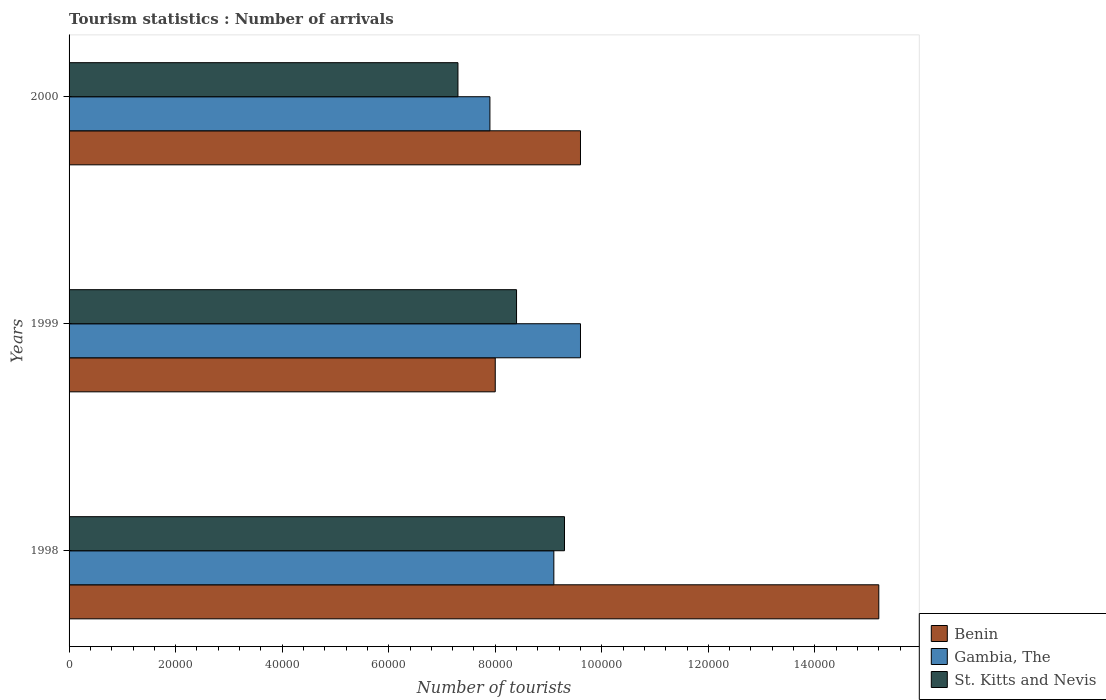How many different coloured bars are there?
Your answer should be very brief. 3. Are the number of bars per tick equal to the number of legend labels?
Keep it short and to the point. Yes. Are the number of bars on each tick of the Y-axis equal?
Provide a succinct answer. Yes. How many bars are there on the 3rd tick from the top?
Keep it short and to the point. 3. What is the label of the 1st group of bars from the top?
Provide a succinct answer. 2000. In how many cases, is the number of bars for a given year not equal to the number of legend labels?
Offer a terse response. 0. What is the number of tourist arrivals in St. Kitts and Nevis in 1998?
Keep it short and to the point. 9.30e+04. Across all years, what is the maximum number of tourist arrivals in Benin?
Keep it short and to the point. 1.52e+05. Across all years, what is the minimum number of tourist arrivals in St. Kitts and Nevis?
Keep it short and to the point. 7.30e+04. What is the total number of tourist arrivals in St. Kitts and Nevis in the graph?
Your answer should be very brief. 2.50e+05. What is the difference between the number of tourist arrivals in Benin in 1998 and that in 1999?
Provide a succinct answer. 7.20e+04. What is the difference between the number of tourist arrivals in Gambia, The in 1998 and the number of tourist arrivals in Benin in 1999?
Make the answer very short. 1.10e+04. What is the average number of tourist arrivals in St. Kitts and Nevis per year?
Keep it short and to the point. 8.33e+04. In the year 2000, what is the difference between the number of tourist arrivals in St. Kitts and Nevis and number of tourist arrivals in Gambia, The?
Provide a succinct answer. -6000. In how many years, is the number of tourist arrivals in St. Kitts and Nevis greater than 144000 ?
Your answer should be very brief. 0. What is the ratio of the number of tourist arrivals in Gambia, The in 1998 to that in 2000?
Give a very brief answer. 1.15. What is the difference between the highest and the second highest number of tourist arrivals in Gambia, The?
Ensure brevity in your answer.  5000. What is the difference between the highest and the lowest number of tourist arrivals in Benin?
Offer a very short reply. 7.20e+04. Is the sum of the number of tourist arrivals in Gambia, The in 1999 and 2000 greater than the maximum number of tourist arrivals in Benin across all years?
Keep it short and to the point. Yes. What does the 3rd bar from the top in 2000 represents?
Provide a short and direct response. Benin. What does the 3rd bar from the bottom in 1999 represents?
Provide a short and direct response. St. Kitts and Nevis. Is it the case that in every year, the sum of the number of tourist arrivals in St. Kitts and Nevis and number of tourist arrivals in Gambia, The is greater than the number of tourist arrivals in Benin?
Your answer should be compact. Yes. How many bars are there?
Keep it short and to the point. 9. Are the values on the major ticks of X-axis written in scientific E-notation?
Make the answer very short. No. Does the graph contain any zero values?
Provide a short and direct response. No. How many legend labels are there?
Your answer should be compact. 3. What is the title of the graph?
Make the answer very short. Tourism statistics : Number of arrivals. Does "Benin" appear as one of the legend labels in the graph?
Make the answer very short. Yes. What is the label or title of the X-axis?
Keep it short and to the point. Number of tourists. What is the label or title of the Y-axis?
Provide a succinct answer. Years. What is the Number of tourists of Benin in 1998?
Keep it short and to the point. 1.52e+05. What is the Number of tourists in Gambia, The in 1998?
Offer a terse response. 9.10e+04. What is the Number of tourists in St. Kitts and Nevis in 1998?
Make the answer very short. 9.30e+04. What is the Number of tourists in Benin in 1999?
Provide a short and direct response. 8.00e+04. What is the Number of tourists of Gambia, The in 1999?
Keep it short and to the point. 9.60e+04. What is the Number of tourists in St. Kitts and Nevis in 1999?
Offer a terse response. 8.40e+04. What is the Number of tourists in Benin in 2000?
Your answer should be very brief. 9.60e+04. What is the Number of tourists in Gambia, The in 2000?
Ensure brevity in your answer.  7.90e+04. What is the Number of tourists in St. Kitts and Nevis in 2000?
Your answer should be compact. 7.30e+04. Across all years, what is the maximum Number of tourists of Benin?
Keep it short and to the point. 1.52e+05. Across all years, what is the maximum Number of tourists of Gambia, The?
Your answer should be compact. 9.60e+04. Across all years, what is the maximum Number of tourists in St. Kitts and Nevis?
Provide a succinct answer. 9.30e+04. Across all years, what is the minimum Number of tourists in Gambia, The?
Your answer should be compact. 7.90e+04. Across all years, what is the minimum Number of tourists in St. Kitts and Nevis?
Your response must be concise. 7.30e+04. What is the total Number of tourists of Benin in the graph?
Make the answer very short. 3.28e+05. What is the total Number of tourists in Gambia, The in the graph?
Provide a short and direct response. 2.66e+05. What is the total Number of tourists in St. Kitts and Nevis in the graph?
Provide a succinct answer. 2.50e+05. What is the difference between the Number of tourists in Benin in 1998 and that in 1999?
Ensure brevity in your answer.  7.20e+04. What is the difference between the Number of tourists of Gambia, The in 1998 and that in 1999?
Your response must be concise. -5000. What is the difference between the Number of tourists in St. Kitts and Nevis in 1998 and that in 1999?
Provide a succinct answer. 9000. What is the difference between the Number of tourists in Benin in 1998 and that in 2000?
Ensure brevity in your answer.  5.60e+04. What is the difference between the Number of tourists of Gambia, The in 1998 and that in 2000?
Your answer should be very brief. 1.20e+04. What is the difference between the Number of tourists of Benin in 1999 and that in 2000?
Make the answer very short. -1.60e+04. What is the difference between the Number of tourists of Gambia, The in 1999 and that in 2000?
Provide a short and direct response. 1.70e+04. What is the difference between the Number of tourists in St. Kitts and Nevis in 1999 and that in 2000?
Make the answer very short. 1.10e+04. What is the difference between the Number of tourists in Benin in 1998 and the Number of tourists in Gambia, The in 1999?
Offer a terse response. 5.60e+04. What is the difference between the Number of tourists in Benin in 1998 and the Number of tourists in St. Kitts and Nevis in 1999?
Offer a terse response. 6.80e+04. What is the difference between the Number of tourists in Gambia, The in 1998 and the Number of tourists in St. Kitts and Nevis in 1999?
Your response must be concise. 7000. What is the difference between the Number of tourists in Benin in 1998 and the Number of tourists in Gambia, The in 2000?
Give a very brief answer. 7.30e+04. What is the difference between the Number of tourists of Benin in 1998 and the Number of tourists of St. Kitts and Nevis in 2000?
Keep it short and to the point. 7.90e+04. What is the difference between the Number of tourists of Gambia, The in 1998 and the Number of tourists of St. Kitts and Nevis in 2000?
Ensure brevity in your answer.  1.80e+04. What is the difference between the Number of tourists in Benin in 1999 and the Number of tourists in St. Kitts and Nevis in 2000?
Provide a succinct answer. 7000. What is the difference between the Number of tourists of Gambia, The in 1999 and the Number of tourists of St. Kitts and Nevis in 2000?
Provide a succinct answer. 2.30e+04. What is the average Number of tourists in Benin per year?
Ensure brevity in your answer.  1.09e+05. What is the average Number of tourists in Gambia, The per year?
Your response must be concise. 8.87e+04. What is the average Number of tourists in St. Kitts and Nevis per year?
Keep it short and to the point. 8.33e+04. In the year 1998, what is the difference between the Number of tourists of Benin and Number of tourists of Gambia, The?
Provide a short and direct response. 6.10e+04. In the year 1998, what is the difference between the Number of tourists in Benin and Number of tourists in St. Kitts and Nevis?
Your answer should be very brief. 5.90e+04. In the year 1998, what is the difference between the Number of tourists of Gambia, The and Number of tourists of St. Kitts and Nevis?
Give a very brief answer. -2000. In the year 1999, what is the difference between the Number of tourists in Benin and Number of tourists in Gambia, The?
Offer a terse response. -1.60e+04. In the year 1999, what is the difference between the Number of tourists of Benin and Number of tourists of St. Kitts and Nevis?
Your answer should be compact. -4000. In the year 1999, what is the difference between the Number of tourists of Gambia, The and Number of tourists of St. Kitts and Nevis?
Provide a short and direct response. 1.20e+04. In the year 2000, what is the difference between the Number of tourists in Benin and Number of tourists in Gambia, The?
Offer a very short reply. 1.70e+04. In the year 2000, what is the difference between the Number of tourists of Benin and Number of tourists of St. Kitts and Nevis?
Keep it short and to the point. 2.30e+04. In the year 2000, what is the difference between the Number of tourists in Gambia, The and Number of tourists in St. Kitts and Nevis?
Ensure brevity in your answer.  6000. What is the ratio of the Number of tourists in Gambia, The in 1998 to that in 1999?
Keep it short and to the point. 0.95. What is the ratio of the Number of tourists of St. Kitts and Nevis in 1998 to that in 1999?
Offer a terse response. 1.11. What is the ratio of the Number of tourists of Benin in 1998 to that in 2000?
Your answer should be compact. 1.58. What is the ratio of the Number of tourists of Gambia, The in 1998 to that in 2000?
Ensure brevity in your answer.  1.15. What is the ratio of the Number of tourists of St. Kitts and Nevis in 1998 to that in 2000?
Your answer should be compact. 1.27. What is the ratio of the Number of tourists of Gambia, The in 1999 to that in 2000?
Your response must be concise. 1.22. What is the ratio of the Number of tourists in St. Kitts and Nevis in 1999 to that in 2000?
Your answer should be compact. 1.15. What is the difference between the highest and the second highest Number of tourists in Benin?
Give a very brief answer. 5.60e+04. What is the difference between the highest and the second highest Number of tourists of Gambia, The?
Your answer should be compact. 5000. What is the difference between the highest and the second highest Number of tourists of St. Kitts and Nevis?
Give a very brief answer. 9000. What is the difference between the highest and the lowest Number of tourists in Benin?
Your answer should be very brief. 7.20e+04. What is the difference between the highest and the lowest Number of tourists of Gambia, The?
Make the answer very short. 1.70e+04. 